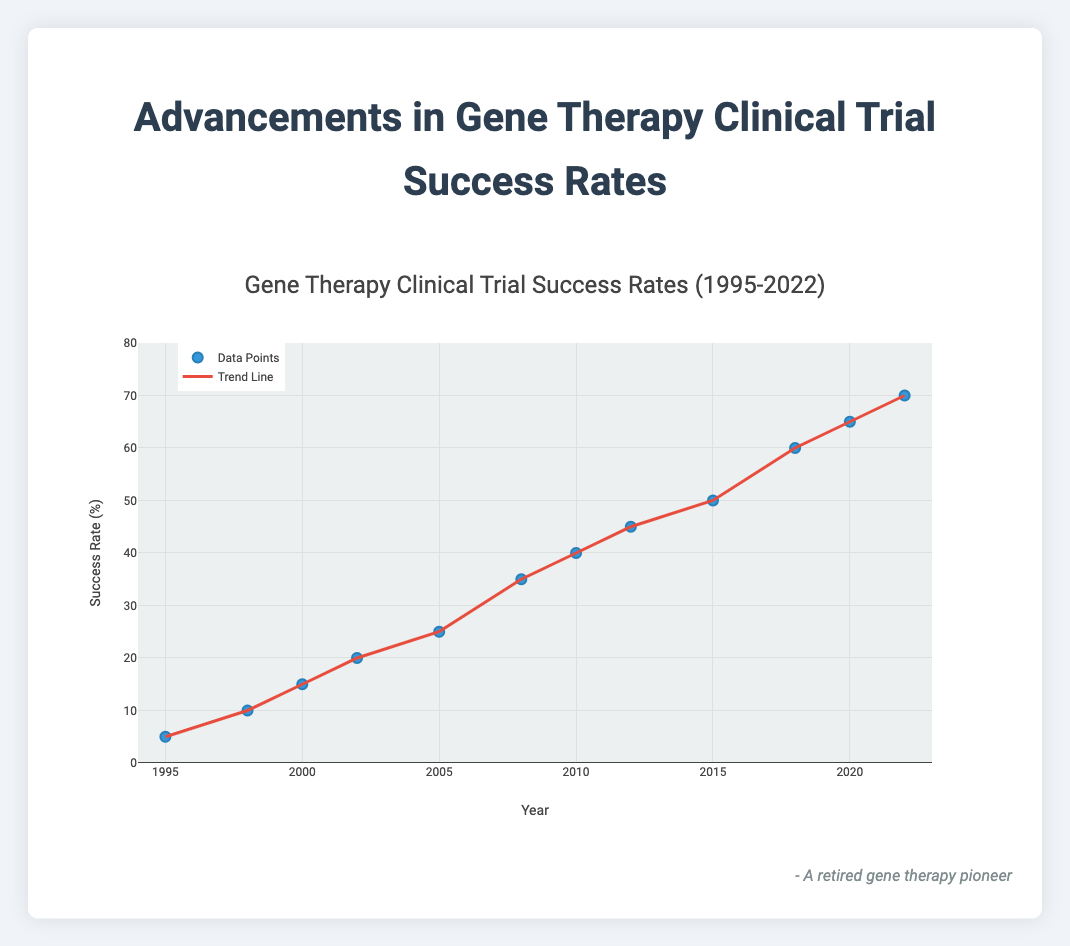What is the title of the figure? The title of the figure is displayed at the top of the plot.
Answer: Gene Therapy Clinical Trial Success Rates (1995-2022) How many data points are plotted in the figure? By counting the markers on the scatter plot, we can see there are twelve data points, corresponding to the years listed from 1995 to 2022.
Answer: 12 What are the axes titles in the figure? The x-axis and y-axis titles are displayed next to each respective axis. The x-axis is labeled "Year," and the y-axis is labeled "Success Rate (%)".
Answer: Year and Success Rate (%) What is the success rate for the year 2022? Looking at the data point corresponding to the year 2022 on the x-axis, we follow vertically to the y-axis to find the success rate.
Answer: 70% How does the success rate change from 1998 to 2010? We find the success rate at 1998 (10%) and at 2010 (40%), and subtract the former from the latter: 40% - 10% = 30%.
Answer: 30% Which year had the highest gene therapy clinical trial success rate? Observing the highest point on the y-axis and its corresponding year on the x-axis reveals the year 2022 had the highest success rate of 70%.
Answer: 2022 What is the average success rate for the years 2000, 2005, and 2010? Adding the success rates for the given years: 15% (2000), 25% (2005), and 40% (2010), and then dividing by 3: (15 + 25 + 40) / 3 = 26.67%.
Answer: 26.67% What was the increase in success rate between the years 2008 and 2018? Finding the success rates for these years: 35% (2008) and 60% (2018), then subtracting the earlier rate from the later one: 60% - 35% = 25%.
Answer: 25% How do the colors of data points and the trend line differ? Observing the figure reveals that the data points are blue and the trend line is red.
Answer: Blue and Red Is there an upward or downward trend in the clinical trial success rates over the years? By observing the trend line moving from lower left to upper right, it indicates an upward trend in success rates from 1995 to 2022.
Answer: Upward 